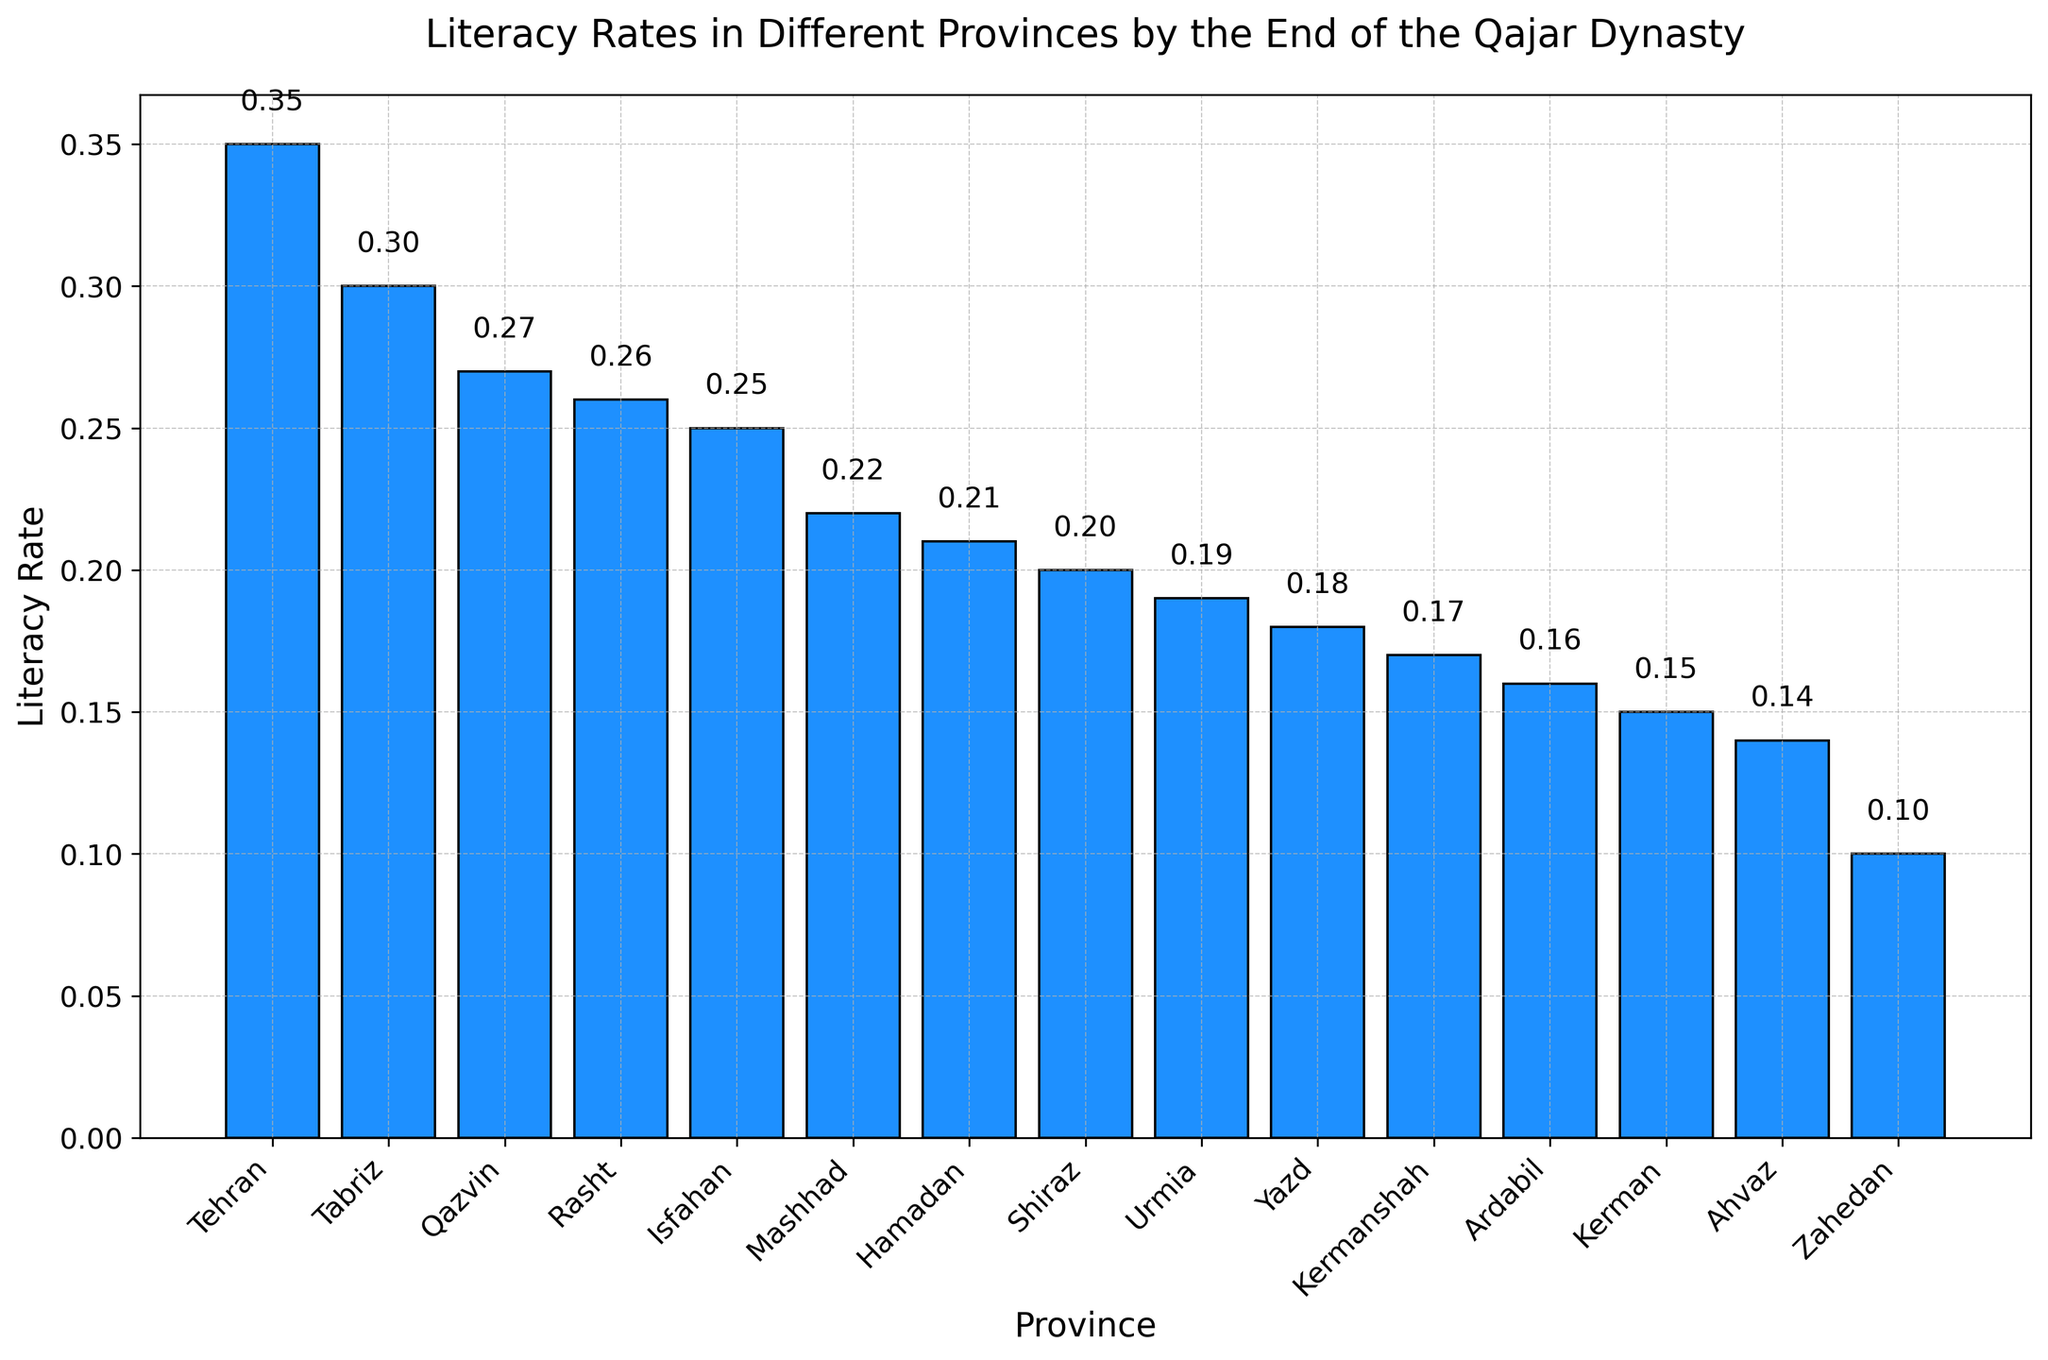Which province has the highest literacy rate? By looking at the height of the bars in the figure, find the bar that reaches the highest point. This bar represents Tehran with a literacy rate of 0.35.
Answer: Tehran Which province has the lowest literacy rate? By checking the bar that is the shortest, we can see that Zahedan has the lowest literacy rate of 0.10.
Answer: Zahedan What is the difference in literacy rates between Tehran and Isfahan? Identify the literacy rates of Tehran (0.35) and Isfahan (0.25) from the bars and subtract the smaller rate from the larger rate (0.35 - 0.25).
Answer: 0.10 What is the average literacy rate of the top three provinces? The top three provinces by literacy rate are Tehran (0.35), Tabriz (0.30), and Qazvin (0.27). Add their literacy rates and divide by three (0.35 + 0.30 + 0.27) / 3.
Answer: 0.31 How many provinces have a literacy rate higher than 0.25? From the figure, count the bars that have a height greater than 0.25. These provinces are Tehran, Tabriz, Qazvin, and Rasht, so there are 4 provinces.
Answer: 4 Which province has a higher literacy rate, Shiraz or Urmia? Compare the heights of the bars for Shiraz (0.20) and Urmia (0.19). Shiraz's bar is slightly higher, indicating a higher literacy rate.
Answer: Shiraz What is the combined literacy rate of the three provinces with the lowest rates? The three provinces with the lowest literacy rates are Zahedan (0.10), Ahvaz (0.14), and Kerman (0.15). Add their literacy rates (0.10 + 0.14 + 0.15).
Answer: 0.39 What is the median literacy rate of all the provinces? To find the median, list all literacy rates in ascending order: 0.10, 0.14, 0.15, 0.16, 0.17, 0.18, 0.19, 0.20, 0.21, 0.22, 0.25, 0.26, 0.27, 0.30, 0.35. The middle value (8th in this list) is the median, which is 0.20.
Answer: 0.20 Which provinces have literacy rates between 0.20 and 0.30? From the figure, identify and list the bars with heights within the range 0.20 to 0.30. These provinces are Shiraz, Mashhad, Hamadan, Urmia, Rasht, and Tabriz.
Answer: Shiraz, Mashhad, Hamadan, Urmia, Rasht, Tabriz 